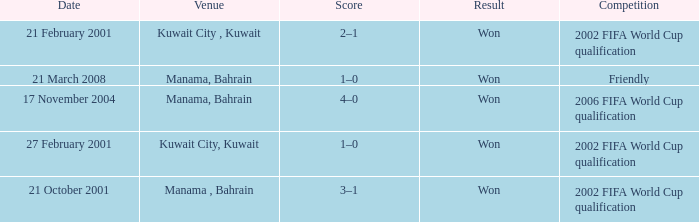What was the final score of the Friendly Competition in Manama, Bahrain? 1–0. 